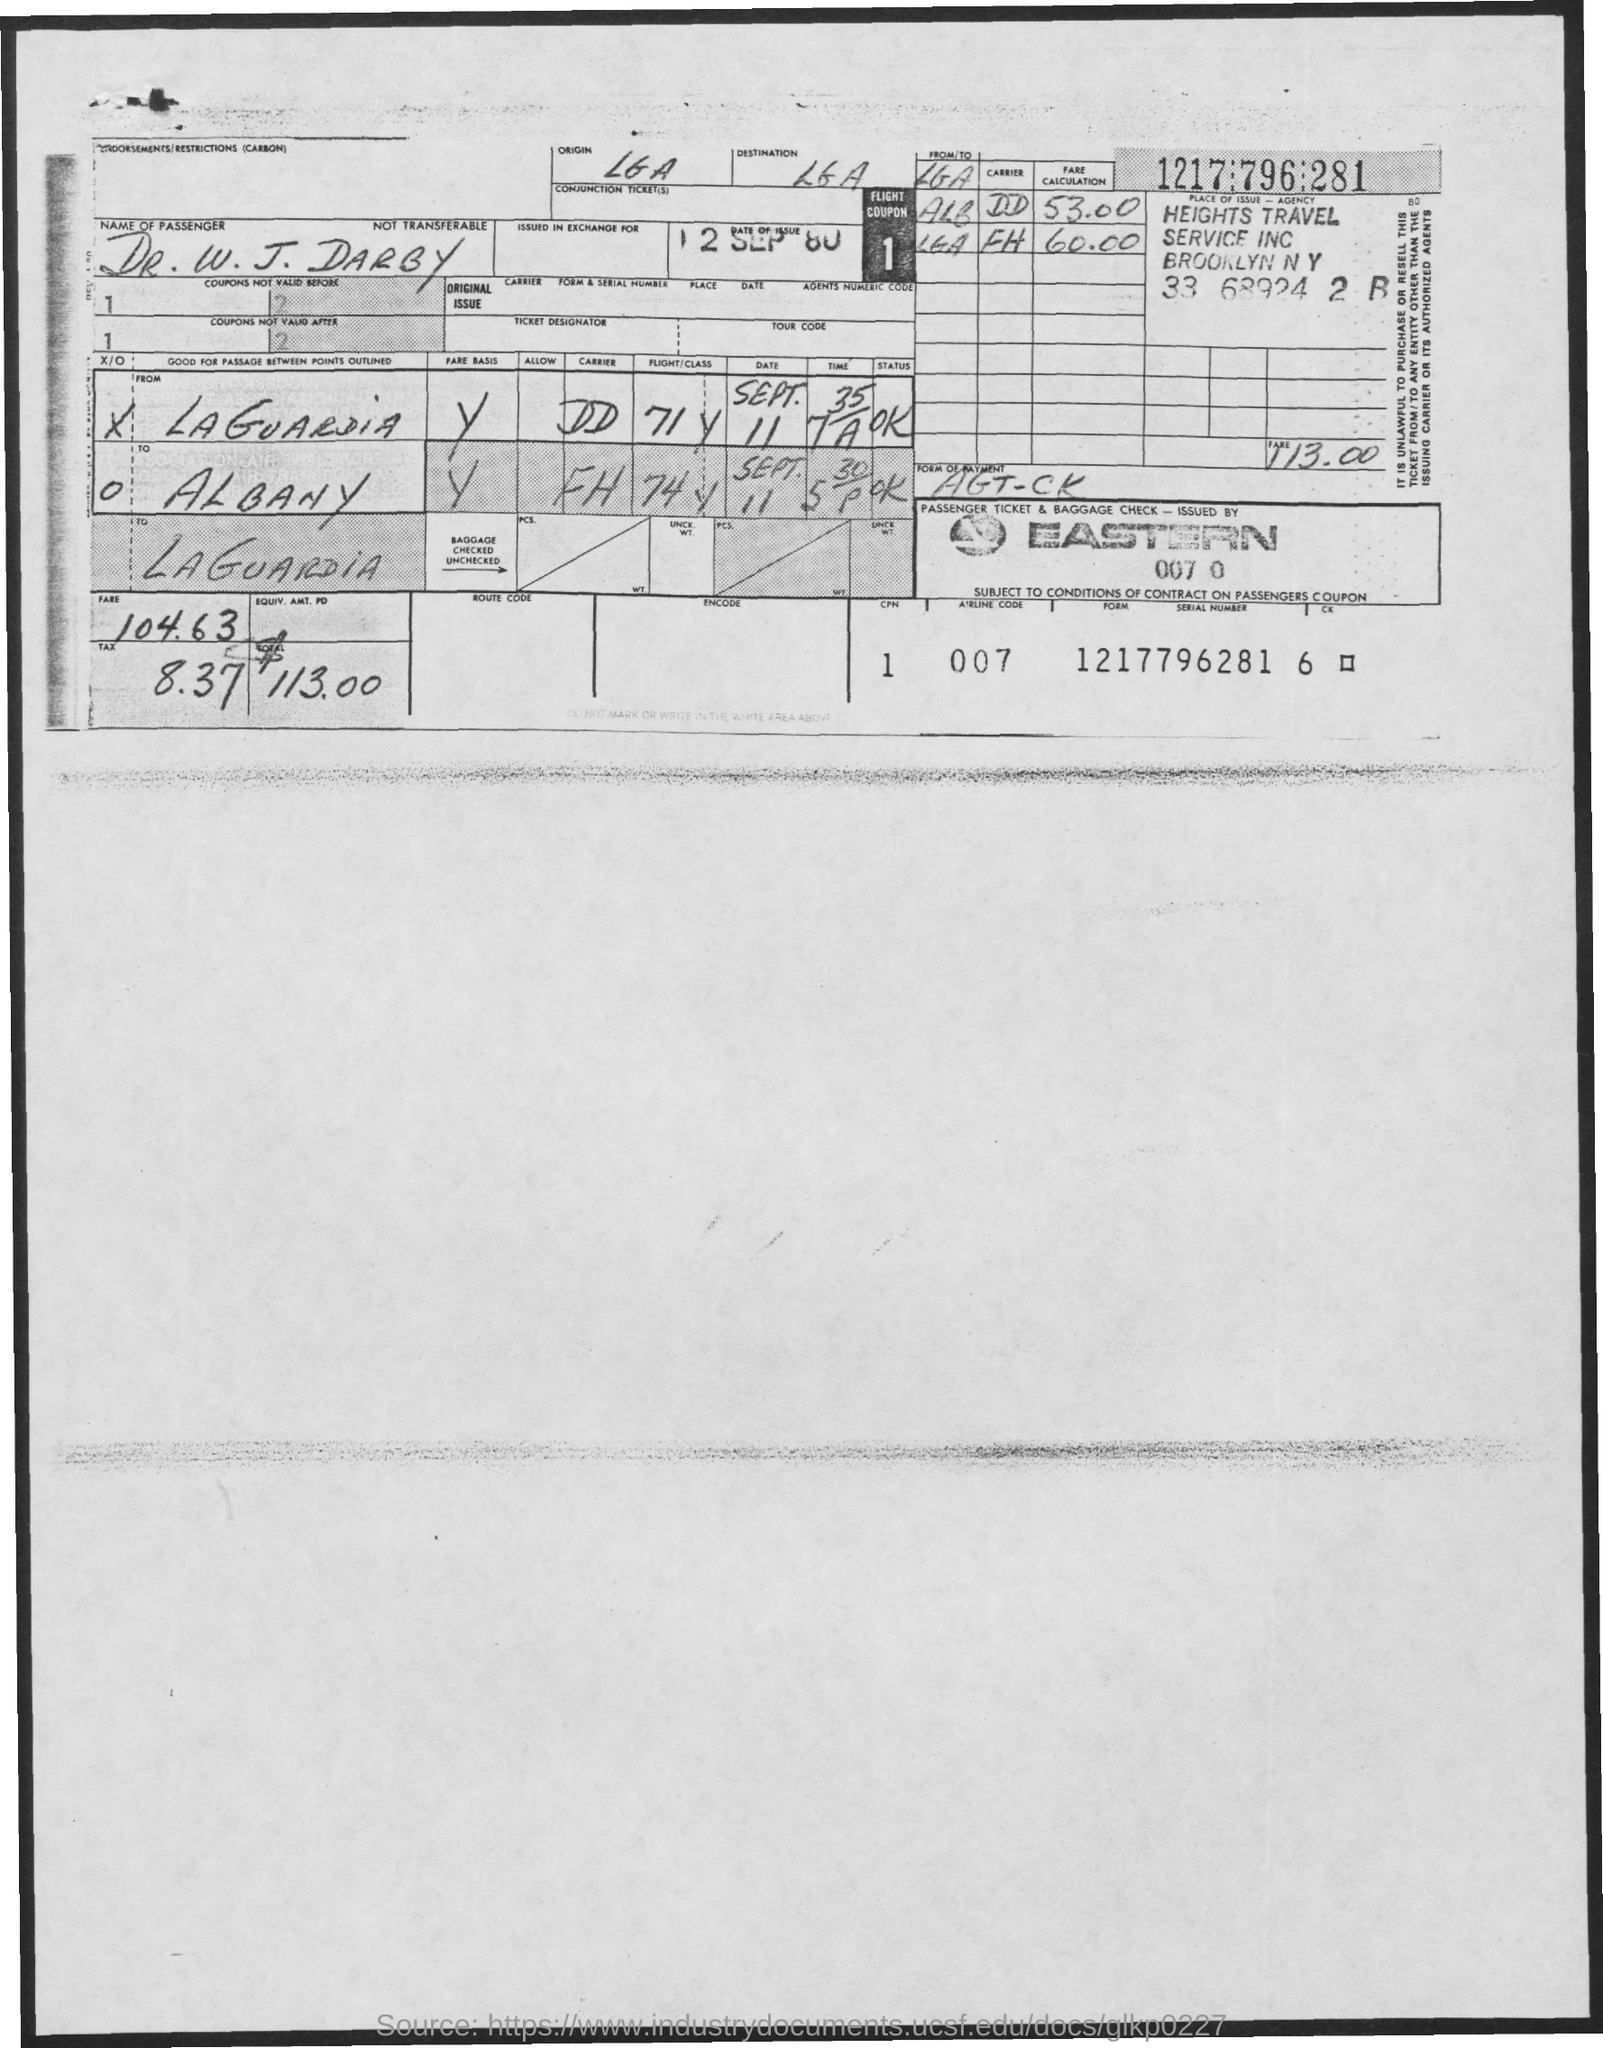What is the date of issue mentioned in the given form ?
Offer a very short reply. 12 SEP 80. What is the amount of fare mentioned in the given form ?
Provide a short and direct response. 104.63. What is the amount of tax mentioned in the given form ?
Offer a very short reply. 8.37. What is the total amount mentioned in the given form ?
Offer a terse response. $113.00. 